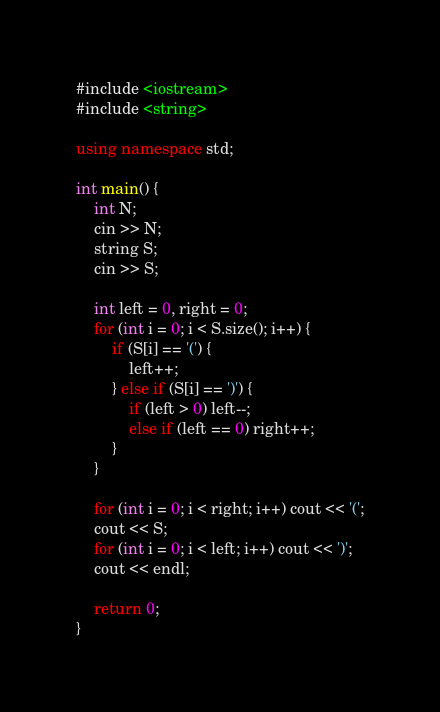<code> <loc_0><loc_0><loc_500><loc_500><_C++_>#include <iostream>
#include <string>

using namespace std;

int main() {
    int N;
    cin >> N;
    string S;
    cin >> S;

    int left = 0, right = 0;
    for (int i = 0; i < S.size(); i++) {
        if (S[i] == '(') {
            left++;
        } else if (S[i] == ')') {
            if (left > 0) left--;
            else if (left == 0) right++;
        }
    }

    for (int i = 0; i < right; i++) cout << '(';
    cout << S;
    for (int i = 0; i < left; i++) cout << ')';
    cout << endl;

    return 0;
}</code> 